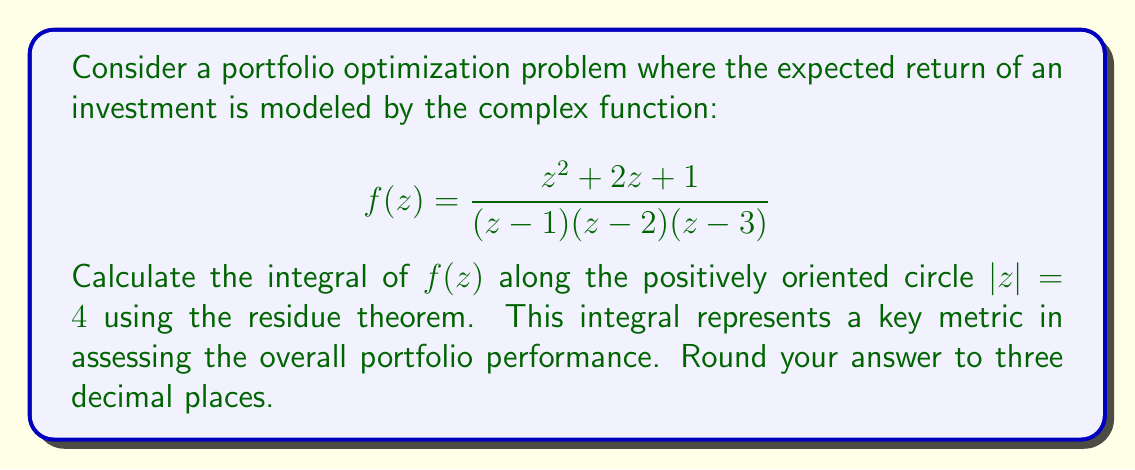Can you answer this question? To solve this problem using the residue theorem, we need to follow these steps:

1) First, identify the singularities of $f(z)$ inside the contour $|z| = 4$. The poles are at $z = 1$, $z = 2$, and $z = 3$, all of which lie inside the circle.

2) The residue theorem states that:

   $$\oint_{|z|=4} f(z) dz = 2\pi i \sum \text{Res}(f, a_k)$$

   where $a_k$ are the singularities inside the contour.

3) We need to calculate the residues at each pole. For a simple pole at $z = a$, the residue is given by:

   $$\text{Res}(f, a) = \lim_{z \to a} (z-a)f(z)$$

4) For $z = 1$:
   $$\text{Res}(f, 1) = \lim_{z \to 1} (z-1)\frac{z^2 + 2z + 1}{(z-1)(z-2)(z-3)} = \frac{1^2 + 2(1) + 1}{(1-2)(1-3)} = \frac{4}{2} = 2$$

5) For $z = 2$:
   $$\text{Res}(f, 2) = \lim_{z \to 2} (z-2)\frac{z^2 + 2z + 1}{(z-1)(z-2)(z-3)} = \frac{2^2 + 2(2) + 1}{(2-1)(2-3)} = -5$$

6) For $z = 3$:
   $$\text{Res}(f, 3) = \lim_{z \to 3} (z-3)\frac{z^2 + 2z + 1}{(z-1)(z-2)(z-3)} = \frac{3^2 + 2(3) + 1}{(3-1)(3-2)} = 7$$

7) Sum the residues and apply the residue theorem:

   $$\oint_{|z|=4} f(z) dz = 2\pi i (2 - 5 + 7) = 2\pi i (4) = 8\pi i$$

8) The question asks for the value of the integral, not $2\pi i$ times the sum of residues. So our final answer is $8\pi i$.

9) Converting to decimal form and rounding to three decimal places:
   $8\pi i \approx 25.133i$
Answer: $25.133i$ 